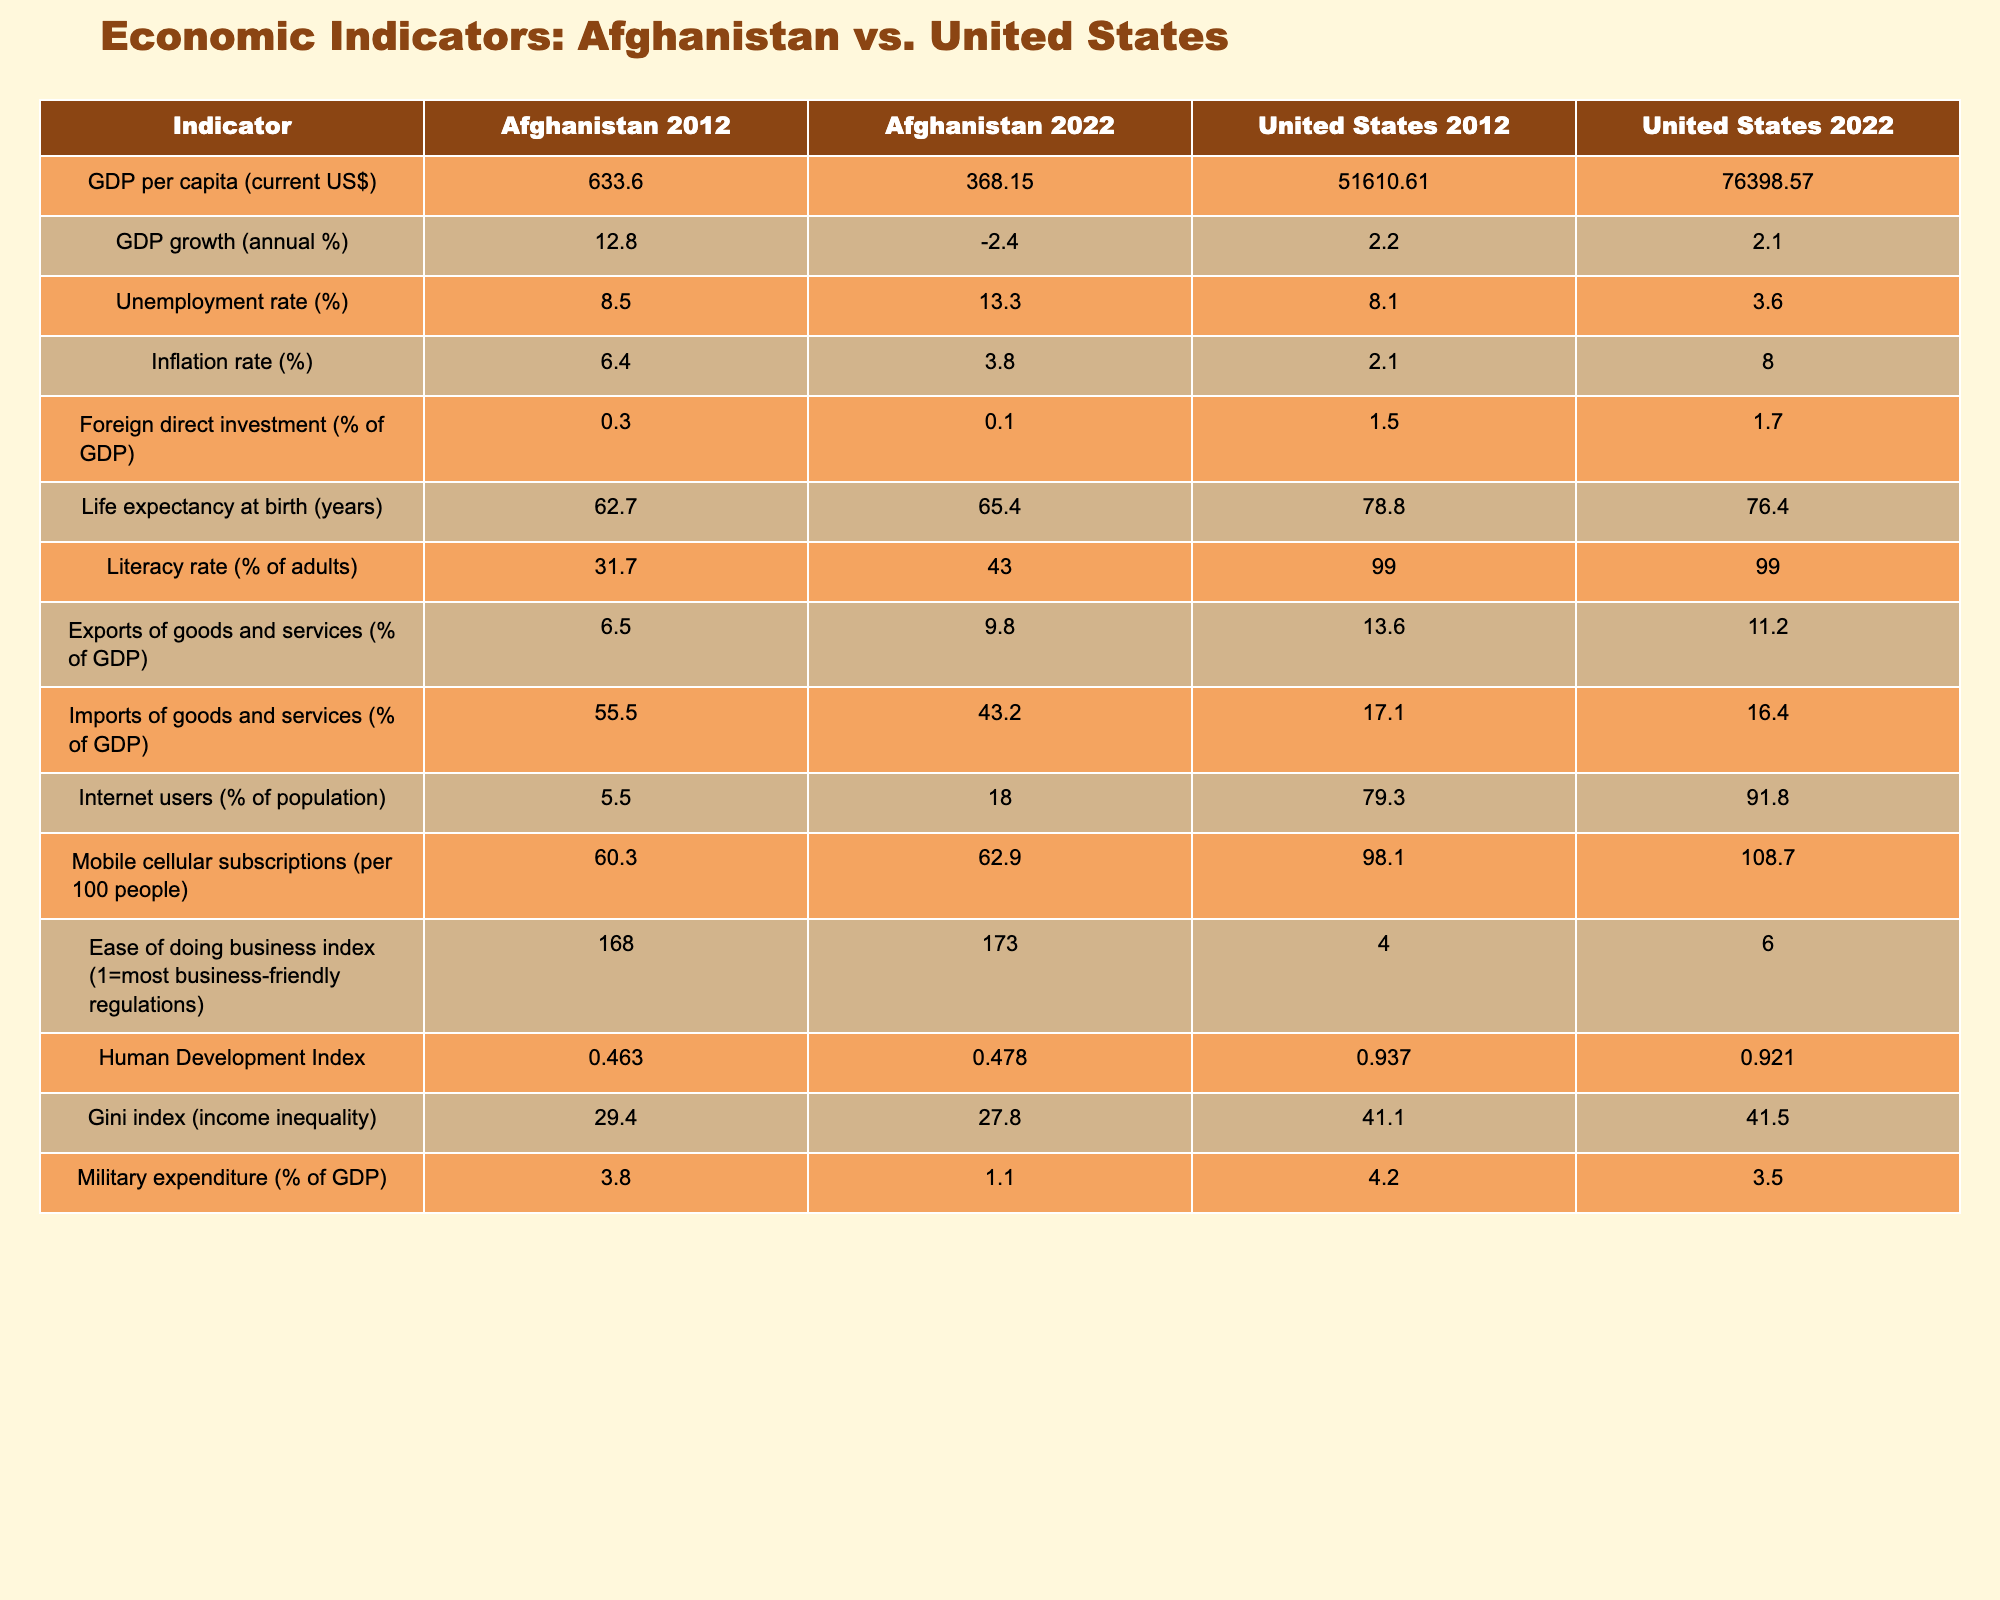What was the GDP per capita in Afghanistan in 2012? The table indicates that the GDP per capita for Afghanistan in 2012 was $633.60.
Answer: 633.60 What is the change in the unemployment rate in the United States from 2012 to 2022? In 2012, the unemployment rate in the United States was 8.1%, and in 2022 it decreased to 3.6%. The change is calculated as 3.6 - 8.1 = -4.5%, indicating a decrease in unemployment.
Answer: -4.5% Is the inflation rate in Afghanistan higher or lower than in the United States in 2022? The inflation rate in Afghanistan in 2022 is 3.8%, and in the United States, it is 8.0%. Since 3.8% is less than 8.0%, the inflation rate in Afghanistan is lower.
Answer: Lower What was the average GDP growth rate in Afghanistan and the United States in 2022? In 2022, Afghanistan's GDP growth rate was -2.4% and the United States' was 2.1%. The average is calculated as (-2.4 + 2.1) / 2 = -0.15%.
Answer: -0.15 Did Afghanistan have a higher or lower literacy rate compared to the United States in 2022? In 2022, Afghanistan had a literacy rate of 43.0%, whereas the United States had a literacy rate of 99.0%. Since 43.0% is less than 99.0%, Afghanistan had a lower literacy rate.
Answer: Lower What is the difference in life expectancy at birth between Afghanistan and the United States in 2022? The life expectancy at birth in Afghanistan for 2022 is 65.4 years and in the United States, it is 76.4 years. The difference is calculated as 76.4 - 65.4 = 11 years.
Answer: 11 What percentage of GDP did Afghanistan receive from Foreign Direct Investment (FDI) in 2022? The table shows that Afghanistan received 0.1% of its GDP from Foreign Direct Investment in 2022.
Answer: 0.1 Is it true that the Gini index for Afghanistan decreased from 2012 to 2022? In 2012, the Gini index for Afghanistan was 29.4, and in 2022 it decreased to 27.8. Since 27.8 is less than 29.4, it is true that the Gini index decreased.
Answer: True What was the total percentage of exports and imports of goods and services relative to GDP for Afghanistan in 2022? The percentage of exports of goods and services for Afghanistan in 2022 is 9.8%, and imports are 43.2%. The total is calculated as 9.8 + 43.2 = 53.0%.
Answer: 53.0 